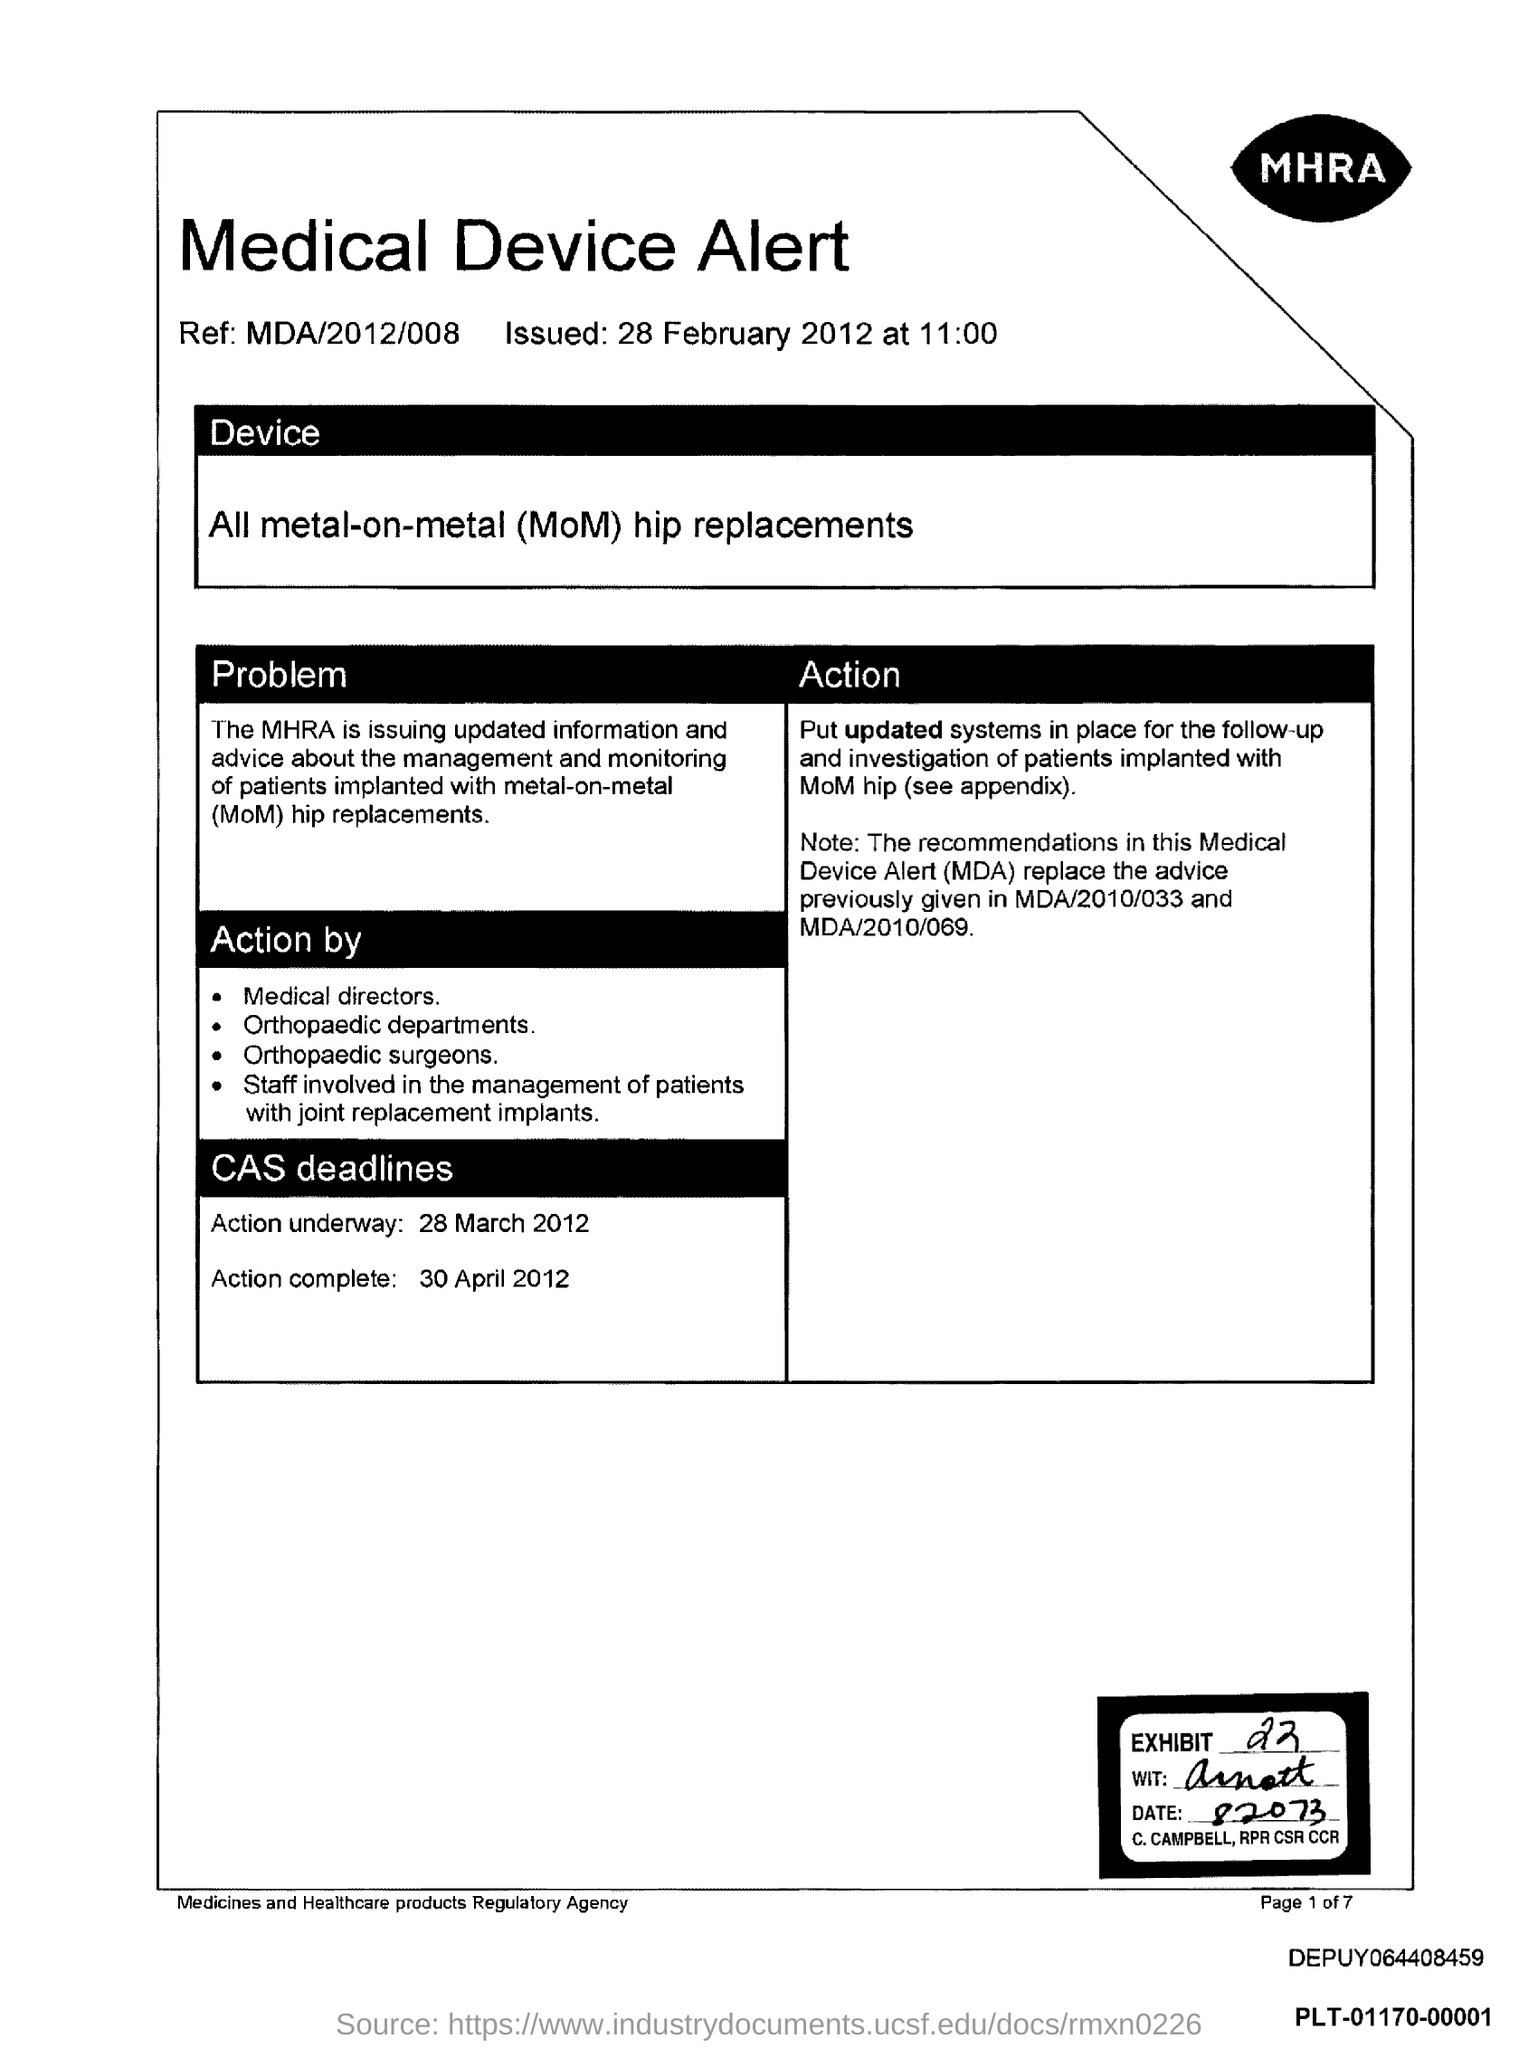Mention a couple of crucial points in this snapshot. The action complete date is 30 April 2012. The exhibit number is 22. The Medicines and Healthcare products Regulatory Agency is the agency in question. The time of issue is 11:00. The Medical Directors are the first in the list of actions taken. 